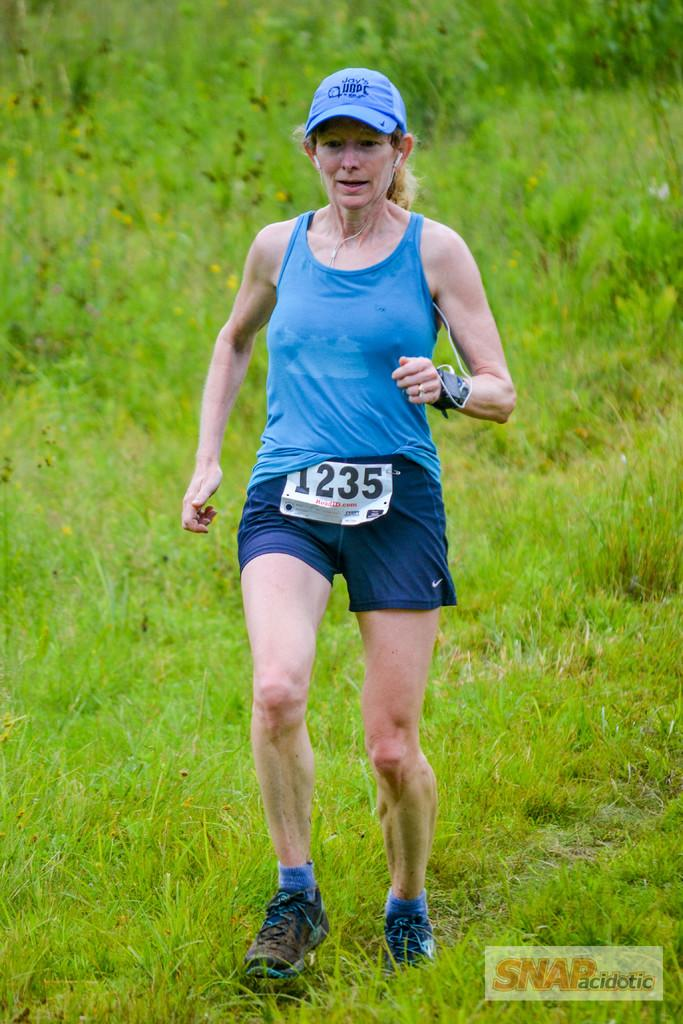<image>
Write a terse but informative summary of the picture. A woman runs cross country wearing the number 1235. 